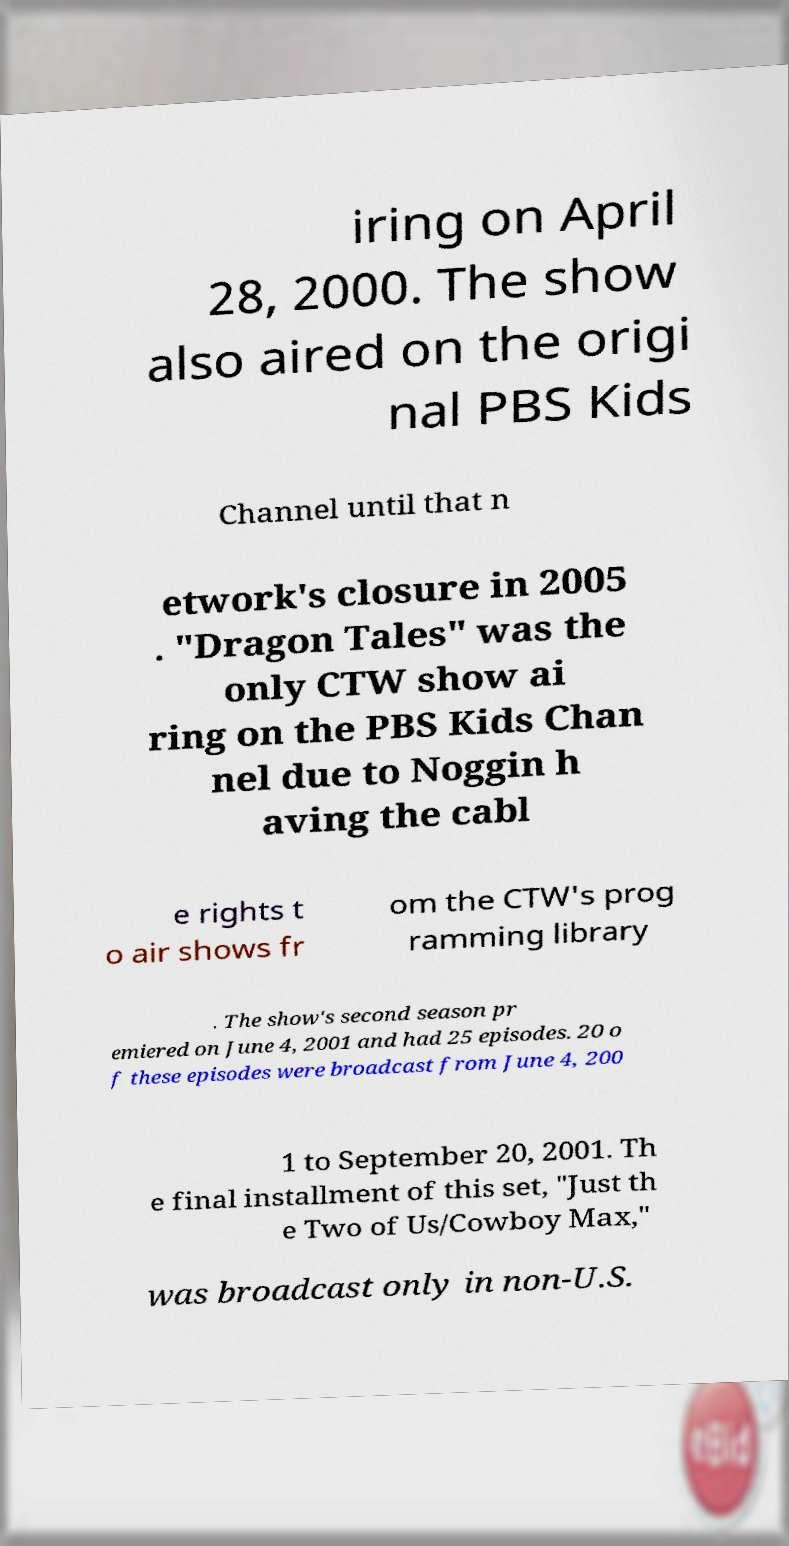Can you read and provide the text displayed in the image?This photo seems to have some interesting text. Can you extract and type it out for me? iring on April 28, 2000. The show also aired on the origi nal PBS Kids Channel until that n etwork's closure in 2005 . "Dragon Tales" was the only CTW show ai ring on the PBS Kids Chan nel due to Noggin h aving the cabl e rights t o air shows fr om the CTW's prog ramming library . The show's second season pr emiered on June 4, 2001 and had 25 episodes. 20 o f these episodes were broadcast from June 4, 200 1 to September 20, 2001. Th e final installment of this set, "Just th e Two of Us/Cowboy Max," was broadcast only in non-U.S. 